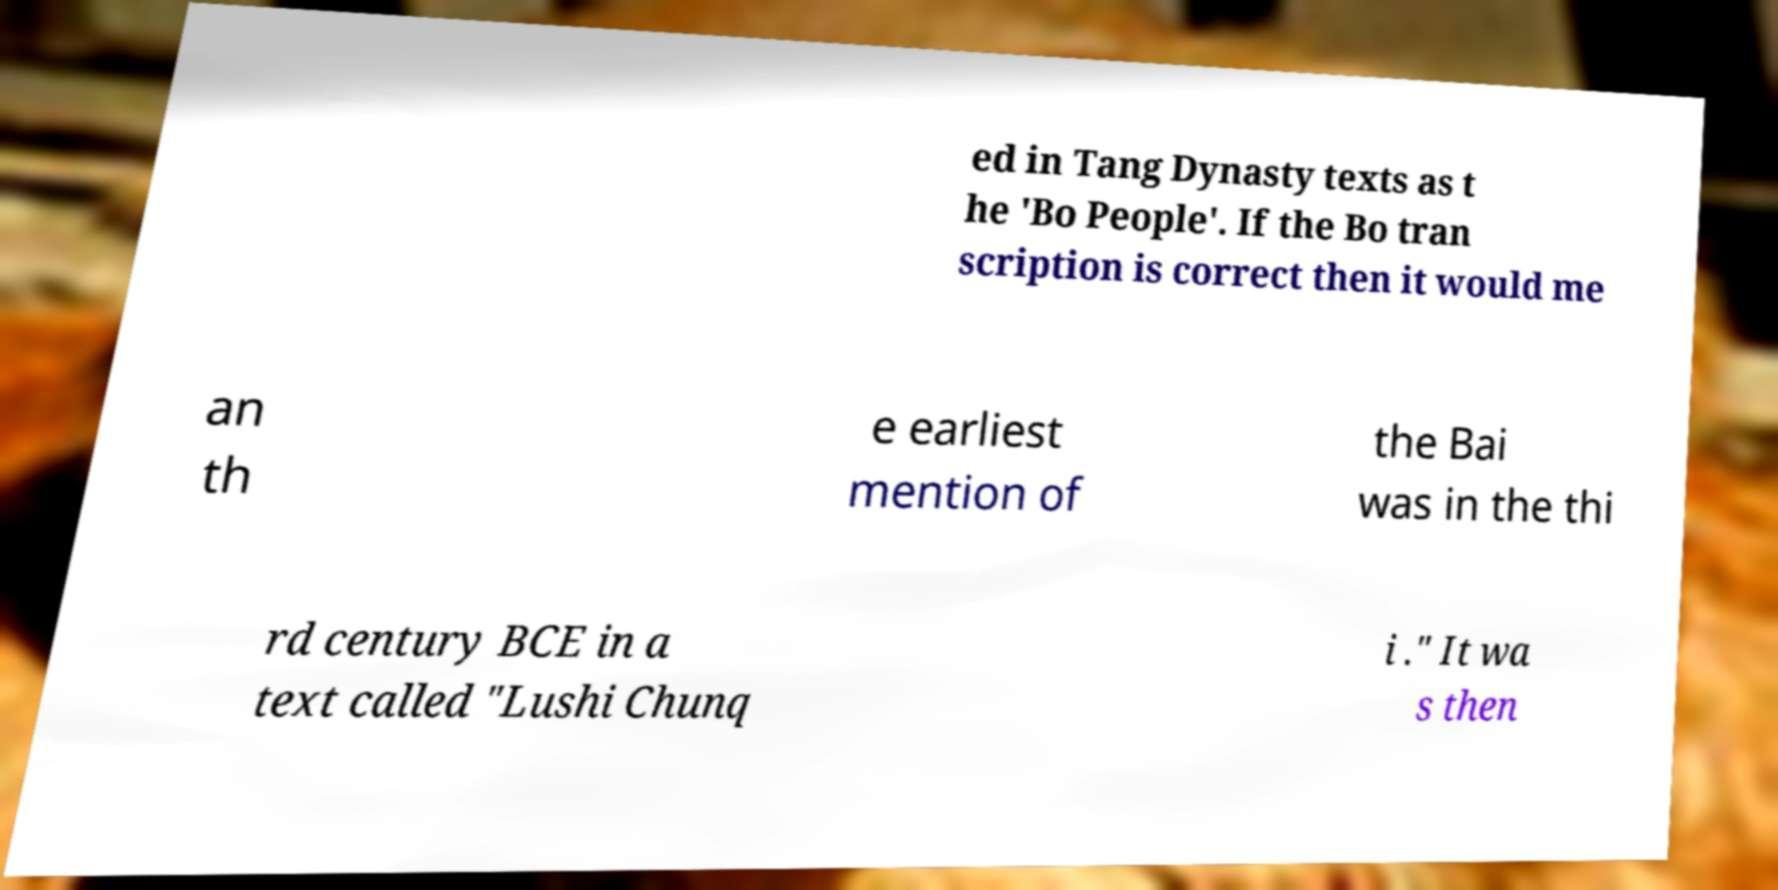Please identify and transcribe the text found in this image. ed in Tang Dynasty texts as t he 'Bo People'. If the Bo tran scription is correct then it would me an th e earliest mention of the Bai was in the thi rd century BCE in a text called "Lushi Chunq i ." It wa s then 